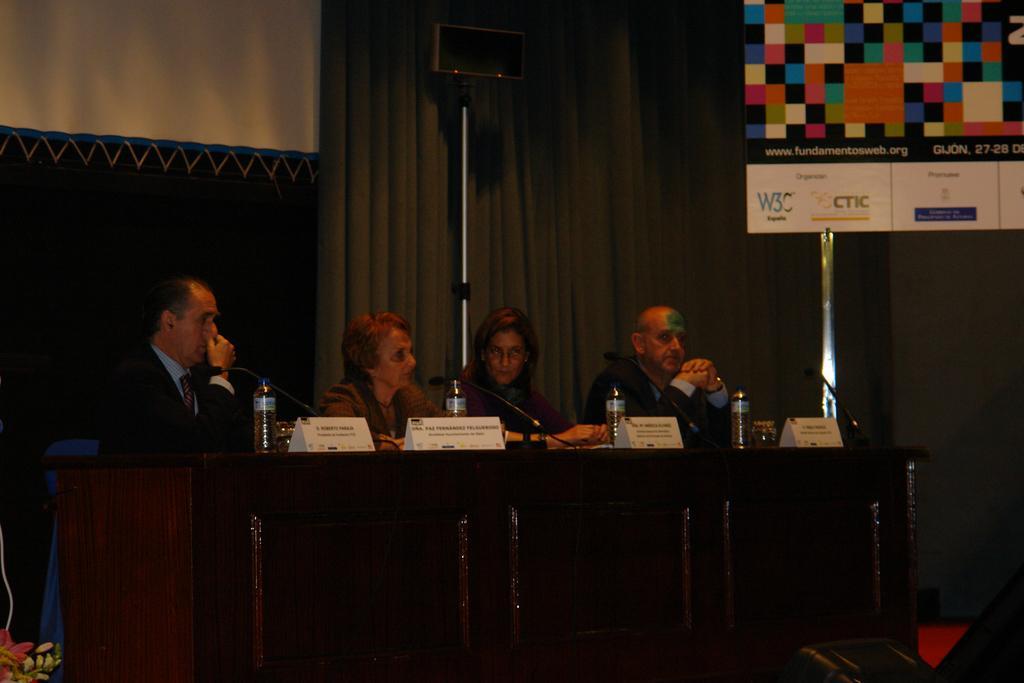In one or two sentences, can you explain what this image depicts? In this picture we can see there are four people sitting on chairs. In front of the people there is a table and on the table there are name boards, bottles and microphones. Behind the people there are curtains and an object on the stand. On the right side of the people there is a banner. 